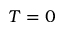Convert formula to latex. <formula><loc_0><loc_0><loc_500><loc_500>T = 0</formula> 